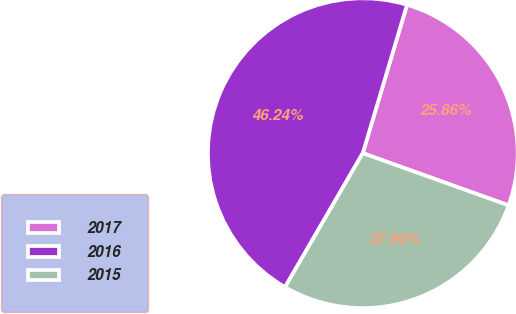Convert chart to OTSL. <chart><loc_0><loc_0><loc_500><loc_500><pie_chart><fcel>2017<fcel>2016<fcel>2015<nl><fcel>25.86%<fcel>46.24%<fcel>27.9%<nl></chart> 